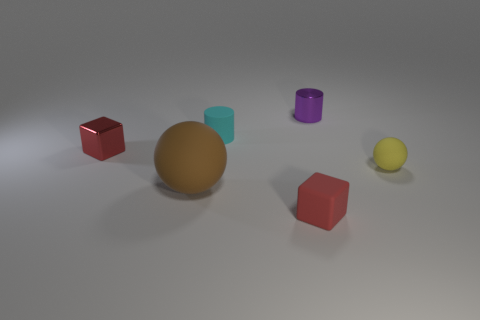Add 1 yellow objects. How many objects exist? 7 Subtract all cylinders. How many objects are left? 4 Add 1 brown blocks. How many brown blocks exist? 1 Subtract 0 green spheres. How many objects are left? 6 Subtract all matte cylinders. Subtract all tiny blue metallic spheres. How many objects are left? 5 Add 4 tiny matte blocks. How many tiny matte blocks are left? 5 